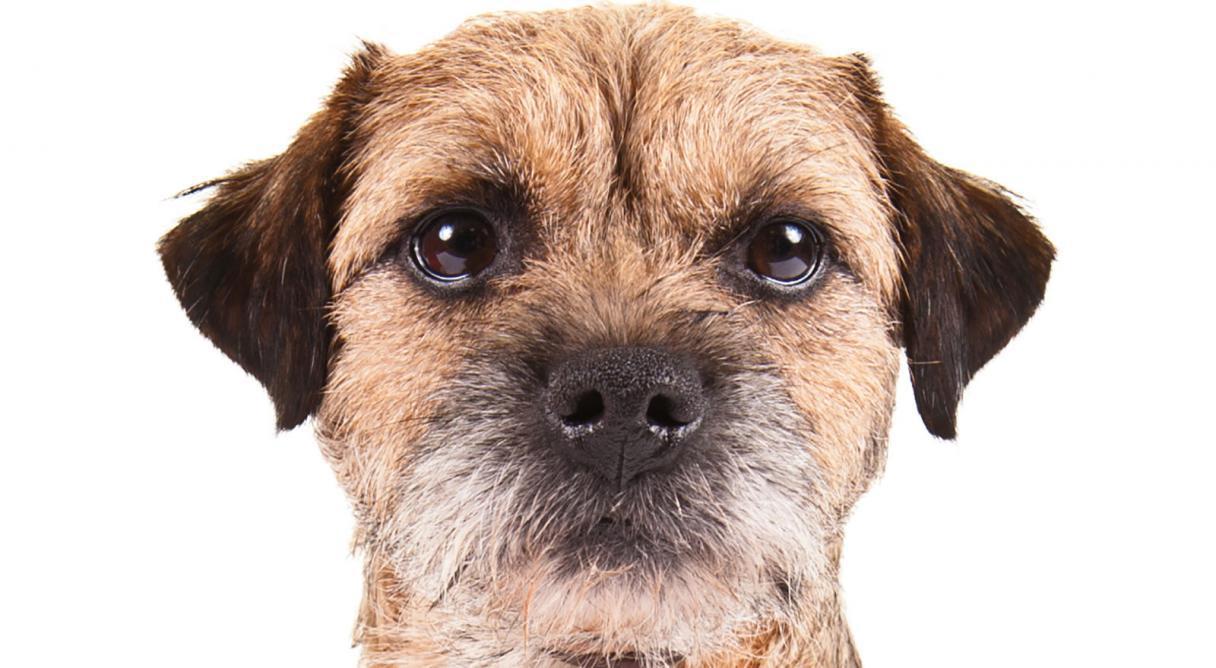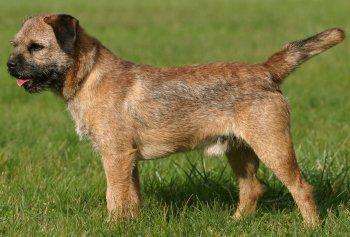The first image is the image on the left, the second image is the image on the right. Given the left and right images, does the statement "The right image contains one dog that is standing on grass." hold true? Answer yes or no. Yes. The first image is the image on the left, the second image is the image on the right. For the images shown, is this caption "A dog stands in profile on the grass with its tail extended." true? Answer yes or no. Yes. 